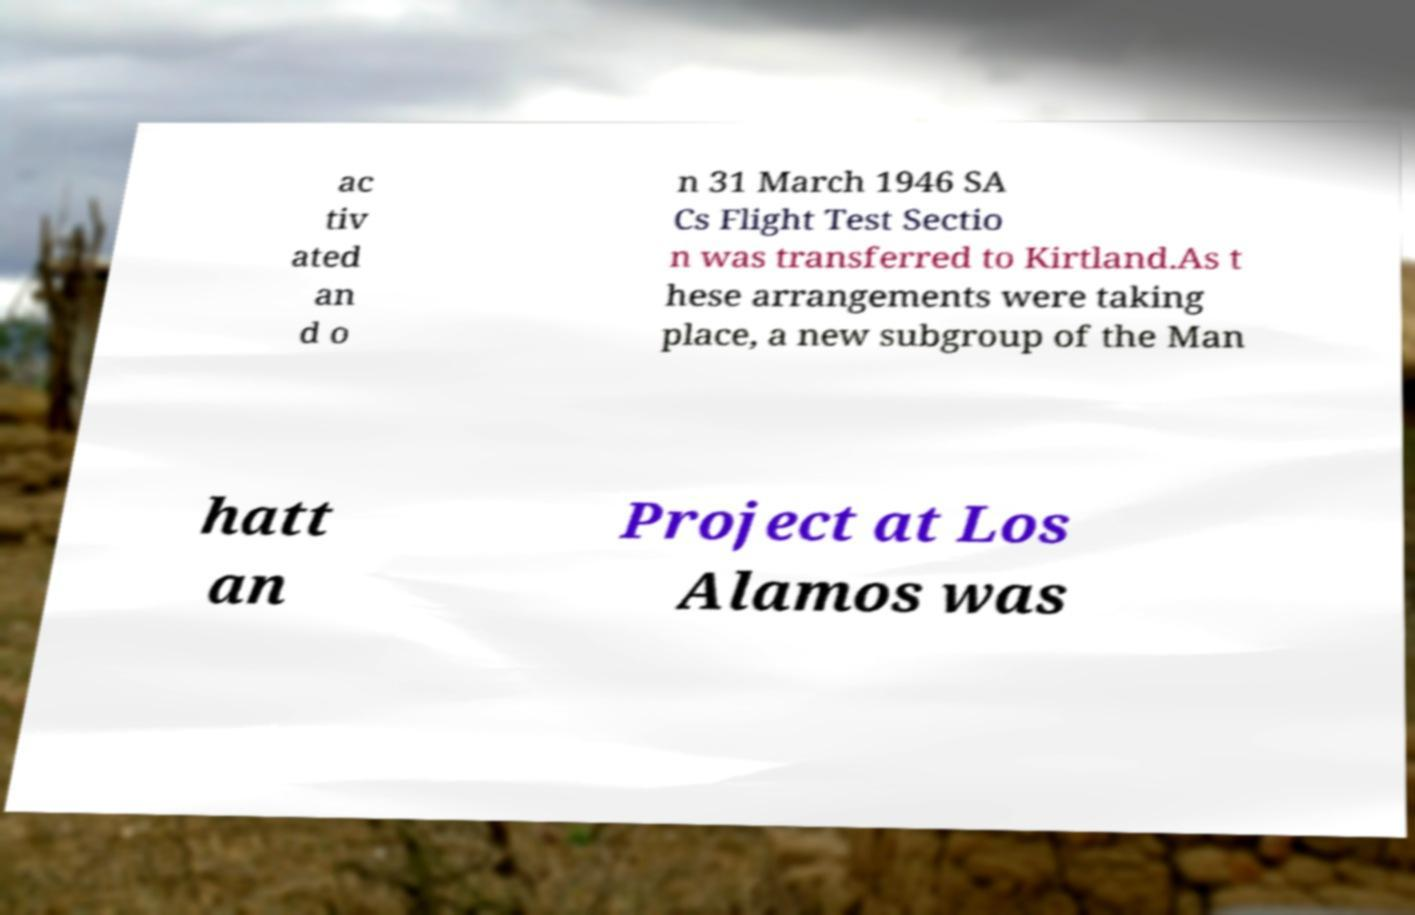Could you assist in decoding the text presented in this image and type it out clearly? ac tiv ated an d o n 31 March 1946 SA Cs Flight Test Sectio n was transferred to Kirtland.As t hese arrangements were taking place, a new subgroup of the Man hatt an Project at Los Alamos was 